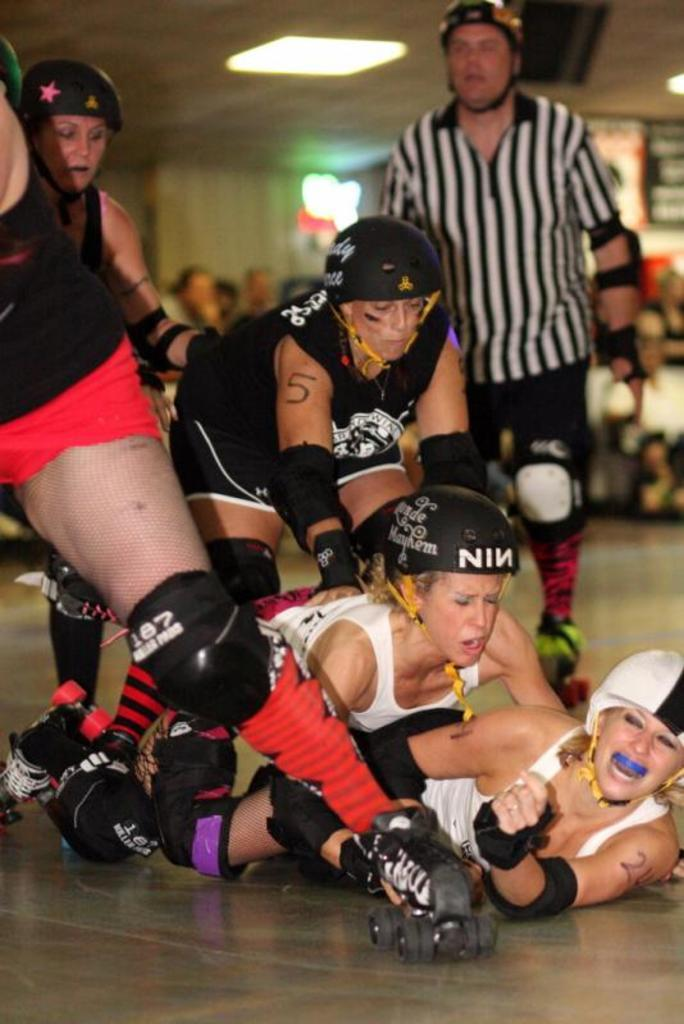Who or what is present in the image? There are people in the image. What protective gear are the people wearing? The people are wearing helmets, knee pads, elbow pads, and skating shoes. What can be seen in the background of the image? There are lights in the background of the image. How would you describe the quality of the image? The image appears blurry. What date is marked on the calendar in the image? There is no calendar present in the image. Can you provide an example of a similar activity to the one being performed in the image? It is difficult to provide an example without knowing the specific activity being performed in the image. However, activities such as rollerblading or inline skating might be similar. 